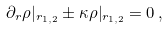Convert formula to latex. <formula><loc_0><loc_0><loc_500><loc_500>\partial _ { r } \rho | _ { r _ { 1 , 2 } } \pm \kappa \rho | _ { r _ { 1 , 2 } } = 0 \, ,</formula> 